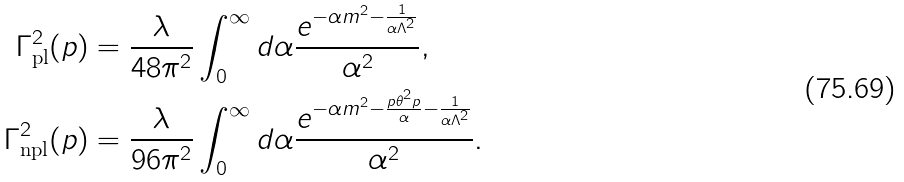Convert formula to latex. <formula><loc_0><loc_0><loc_500><loc_500>\Gamma _ { \text {pl} } ^ { 2 } ( p ) & = \frac { \lambda } { 4 8 \pi ^ { 2 } } \int _ { 0 } ^ { \infty } d \alpha \frac { e ^ { - \alpha m ^ { 2 } - \frac { 1 } { \alpha \Lambda ^ { 2 } } } } { \alpha ^ { 2 } } , \\ \Gamma _ { \text {npl} } ^ { 2 } ( p ) & = \frac { \lambda } { 9 6 \pi ^ { 2 } } \int _ { 0 } ^ { \infty } d \alpha \frac { e ^ { - \alpha m ^ { 2 } - \frac { p \theta ^ { 2 } p } { \alpha } - \frac { 1 } { \alpha \Lambda ^ { 2 } } } } { \alpha ^ { 2 } } .</formula> 